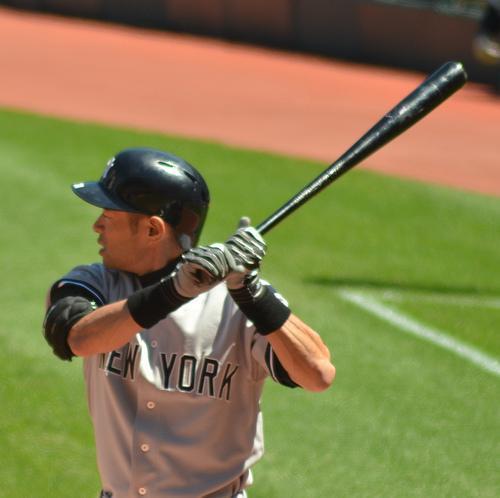How many people are not wearing hats?
Give a very brief answer. 0. 